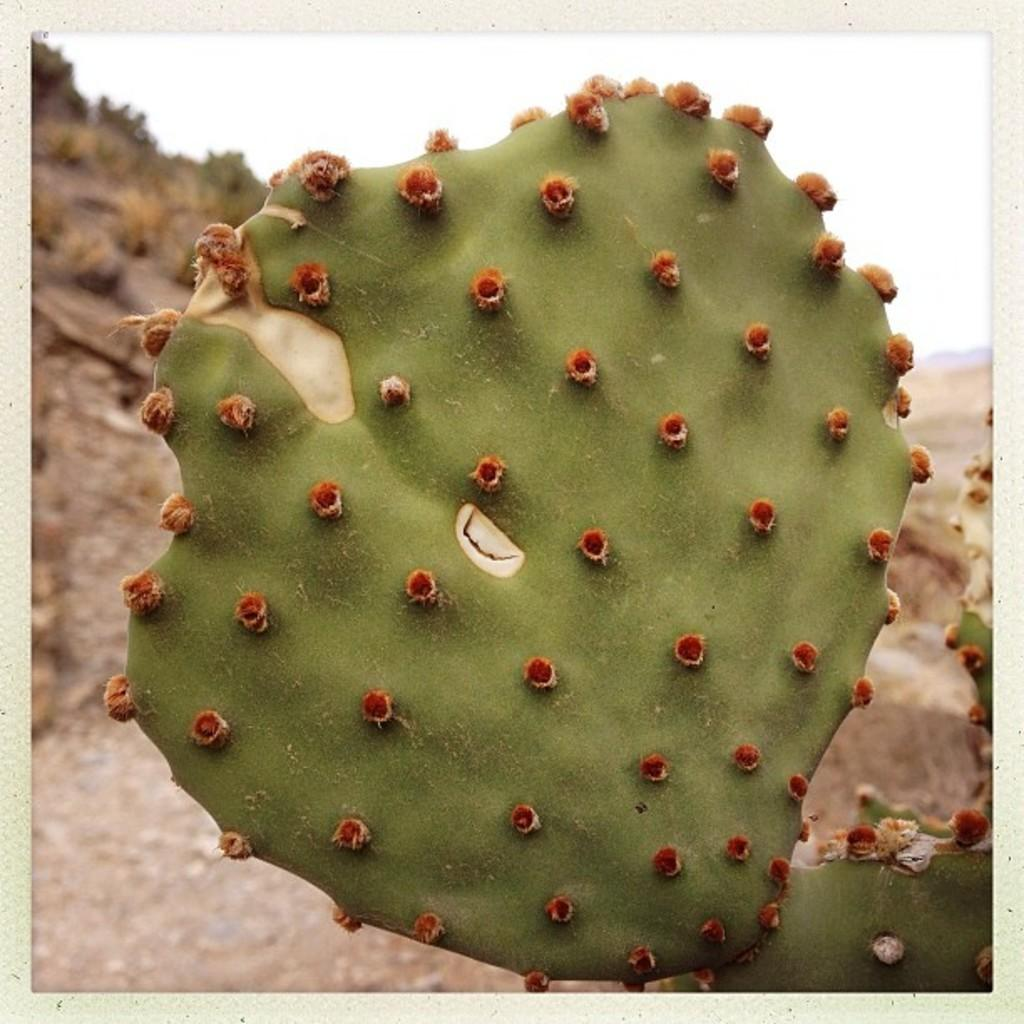What type of plant is in the image? There is a cactus plant in the image. What can be seen in the background of the image? There is soil, stones, shrubs, and hills. Can you describe the terrain in the background of the image? The background of the image features soil, stones, shrubs, and hills. What type of zinc is present in the image? There is no zinc present in the image; it features a cactus plant, soil, stones, shrubs, and hills. What type of stew is being cooked in the image? There is no stew present in the image; it features a cactus plant, soil, stones, shrubs, and hills. 